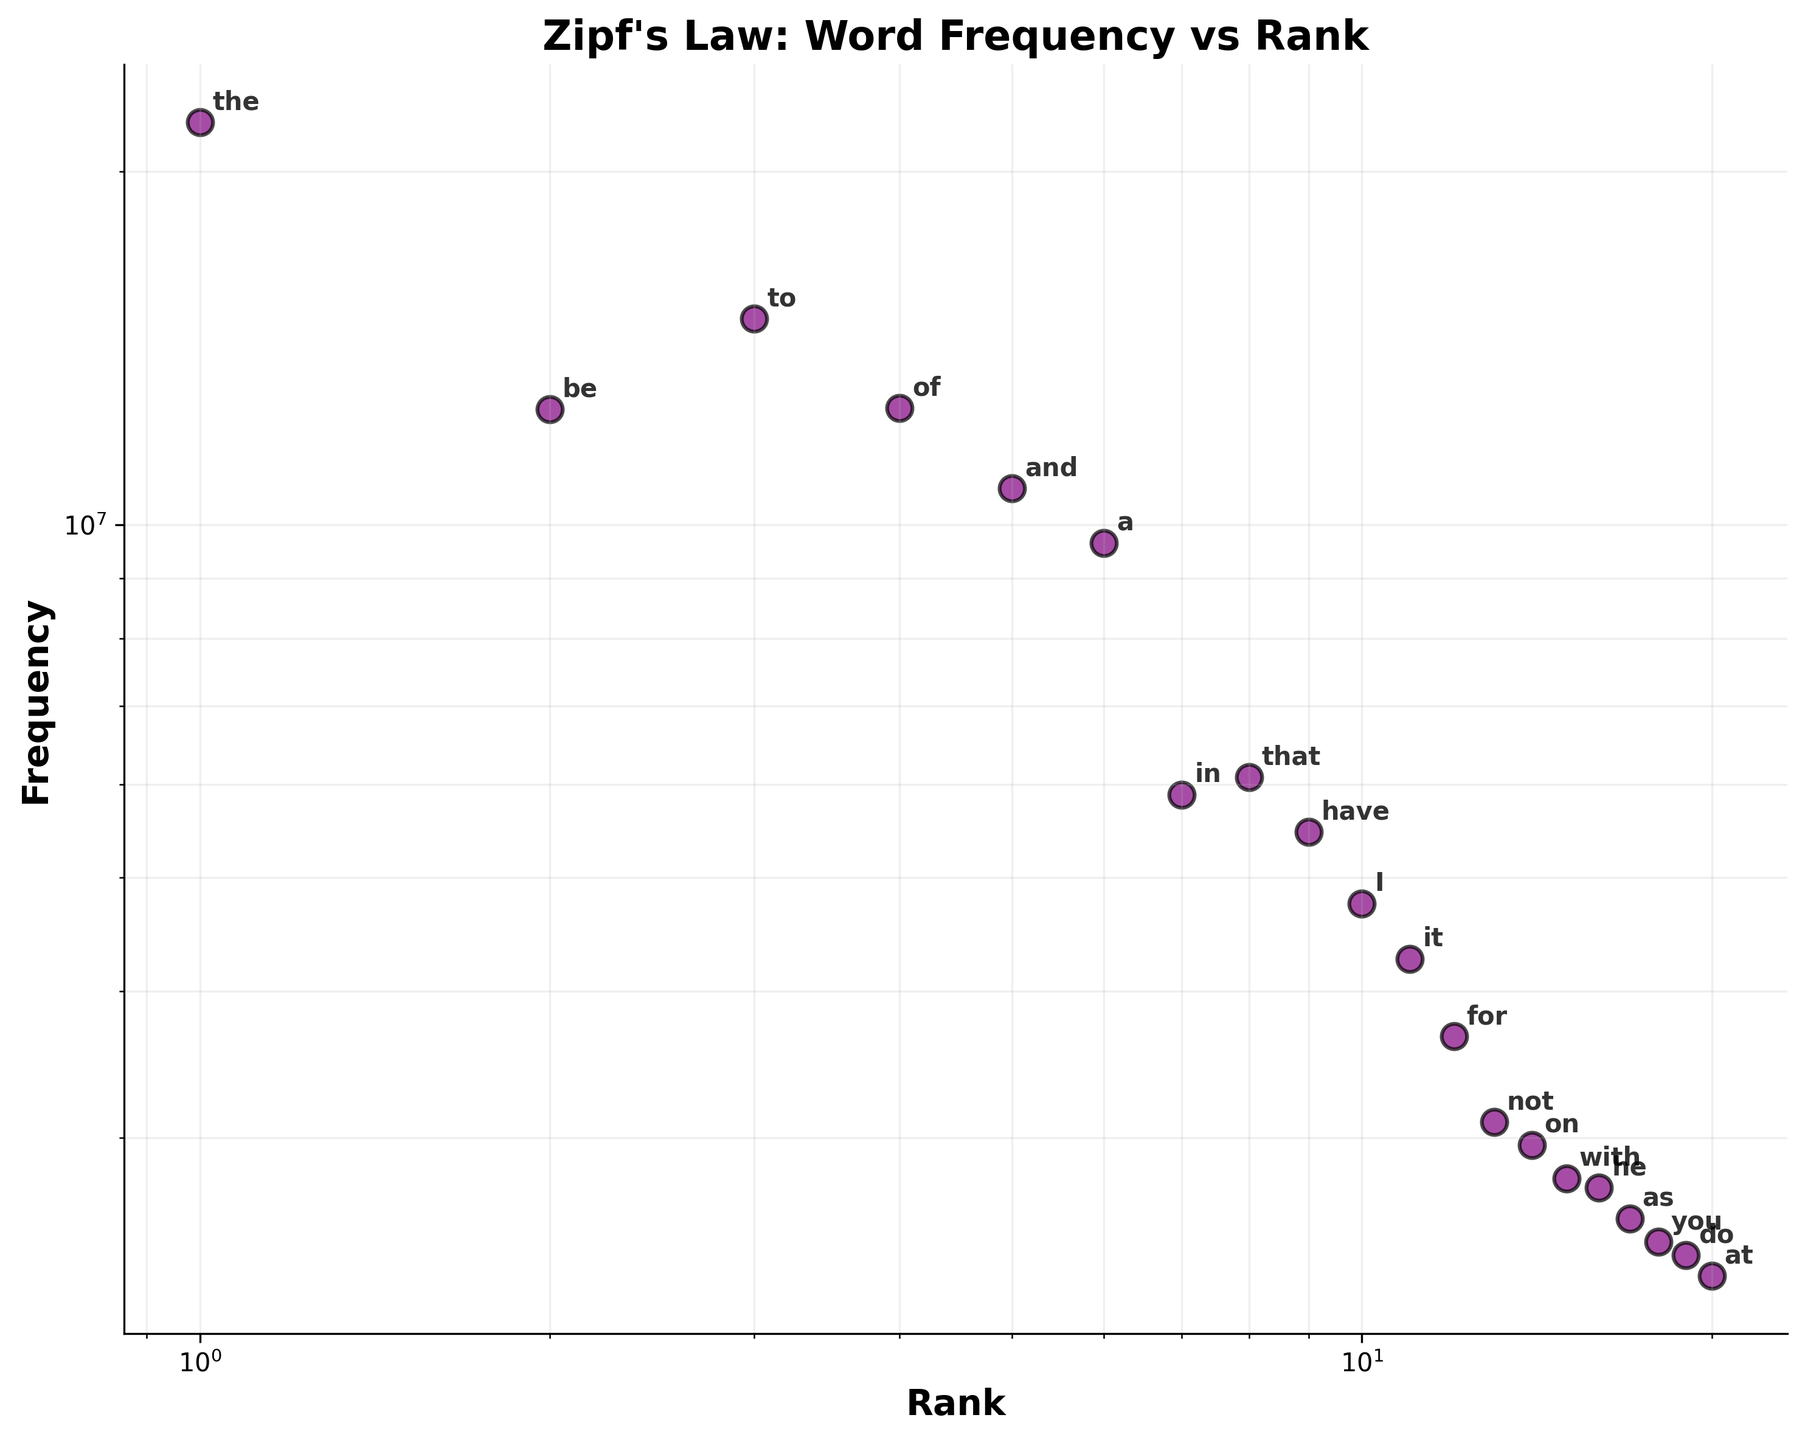What is the title of the scatter plot? The title is located at the top center of the plot and gives a quick overview of what the plot represents. Here, it states "Zipf's Law: Word Frequency vs Rank."
Answer: Zipf's Law: Word Frequency vs Rank How many words are plotted in the scatter plot? To answer this question, count the number of data points or annotations in the scatter plot. Each point represents a word, and there are 20 such annotations.
Answer: 20 Which word has the highest frequency, and what is its rank? Look for the data point annotated with the maximum y-value since frequency is plotted on the y-axis. Additionally, its rank will correspond to the x-value for this point. The word "the" has the highest frequency of 22,038,615, and it is ranked 1st.
Answer: "the", 1 Which word has the lowest frequency, and what is its rank? Identify the data point annotated with the minimum y-value to find the word with the lowest frequency. This word will be ranked 20th, corresponding to its x-value. The word "at" has the lowest frequency of 2,287,523, and it is ranked 20th.
Answer: "at", 20 How does the frequency vary as the rank increases from 1 to 20? Observe the trend in the scatter plot: as rank increases (moves right on the x-axis), the frequency decreases (moves down on the y-axis), demonstrating a negative correlation consistent with Zipf's Law.
Answer: Frequency decreases Compare the frequencies of the words ranked 5th and 10th. Which one is higher? Find the 5th and 10th data points. The word ranked 5th is "and" with a frequency of 10,741,073, and the word ranked 10th is "I" with a frequency of 4,753,202. Since 10,741,073 > 4,753,202, the 5th ranked word has a higher frequency.
Answer: The 5th ranked word Identify two words whose ranks are consecutive and frequencies have the smallest difference. What is that difference? Compare the frequencies of consecutive ranks manually and identify the smallest difference. The closest pairs are "at" (2,287,523) and "do" (2,382,957) with a difference of 95,434.
Answer: "at" and "do", 95,434 Does the plot indicate any outliers in terms of word frequency? To determine potential outliers, examine if any points deviate significantly from the overall decreasing trend. In this plot, all points lie close to the decreasing curve, so no major outliers are visible.
Answer: No How does the grid help in interpreting the log scales of the axes? The grid lines in the log scale help in comparing and estimating values as they indicate powers of 10. They break down the large ranges in a more interpretable form, allowing easier understanding of how a small movement indicates a significant change in value.
Answer: Simplifies comparison and estimation Is the relationship between word rank and frequency linear or nonlinear on the log scales? On log-log scales, a straight-line appearance suggests a power-law relationship (characteristic of Zipf's law), indicating that the relationship is linear in log-log space, but nonlinear in normal scales.
Answer: Linear in log-log space 